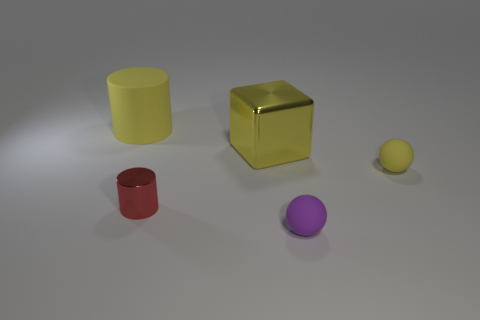Can you tell me what time of day this image might represent? Based on the shadows and the lighting in the image, it appears to be an indoor setup with artificial lighting. Therefore, it does not directly suggest any particular time of day. 